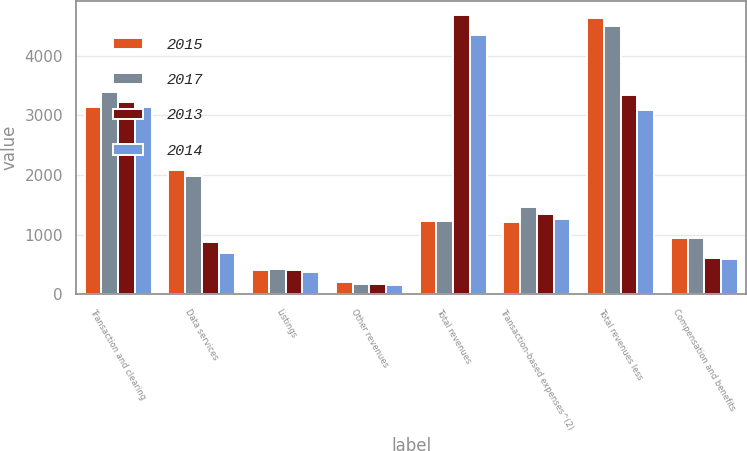Convert chart. <chart><loc_0><loc_0><loc_500><loc_500><stacked_bar_chart><ecel><fcel>Transaction and clearing<fcel>Data services<fcel>Listings<fcel>Other revenues<fcel>Total revenues<fcel>Transaction-based expenses^(2)<fcel>Total revenues less<fcel>Compensation and benefits<nl><fcel>2015<fcel>3131<fcel>2084<fcel>417<fcel>202<fcel>1232.5<fcel>1205<fcel>4629<fcel>937<nl><fcel>2017<fcel>3384<fcel>1978<fcel>419<fcel>177<fcel>1232.5<fcel>1459<fcel>4499<fcel>945<nl><fcel>2013<fcel>3228<fcel>871<fcel>405<fcel>178<fcel>4682<fcel>1344<fcel>3338<fcel>611<nl><fcel>2014<fcel>3144<fcel>691<fcel>367<fcel>150<fcel>4352<fcel>1260<fcel>3092<fcel>592<nl></chart> 